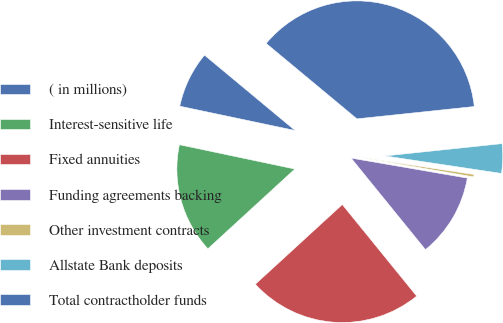Convert chart to OTSL. <chart><loc_0><loc_0><loc_500><loc_500><pie_chart><fcel>( in millions)<fcel>Interest-sensitive life<fcel>Fixed annuities<fcel>Funding agreements backing<fcel>Other investment contracts<fcel>Allstate Bank deposits<fcel>Total contractholder funds<nl><fcel>7.73%<fcel>15.12%<fcel>24.05%<fcel>11.43%<fcel>0.34%<fcel>4.04%<fcel>37.3%<nl></chart> 